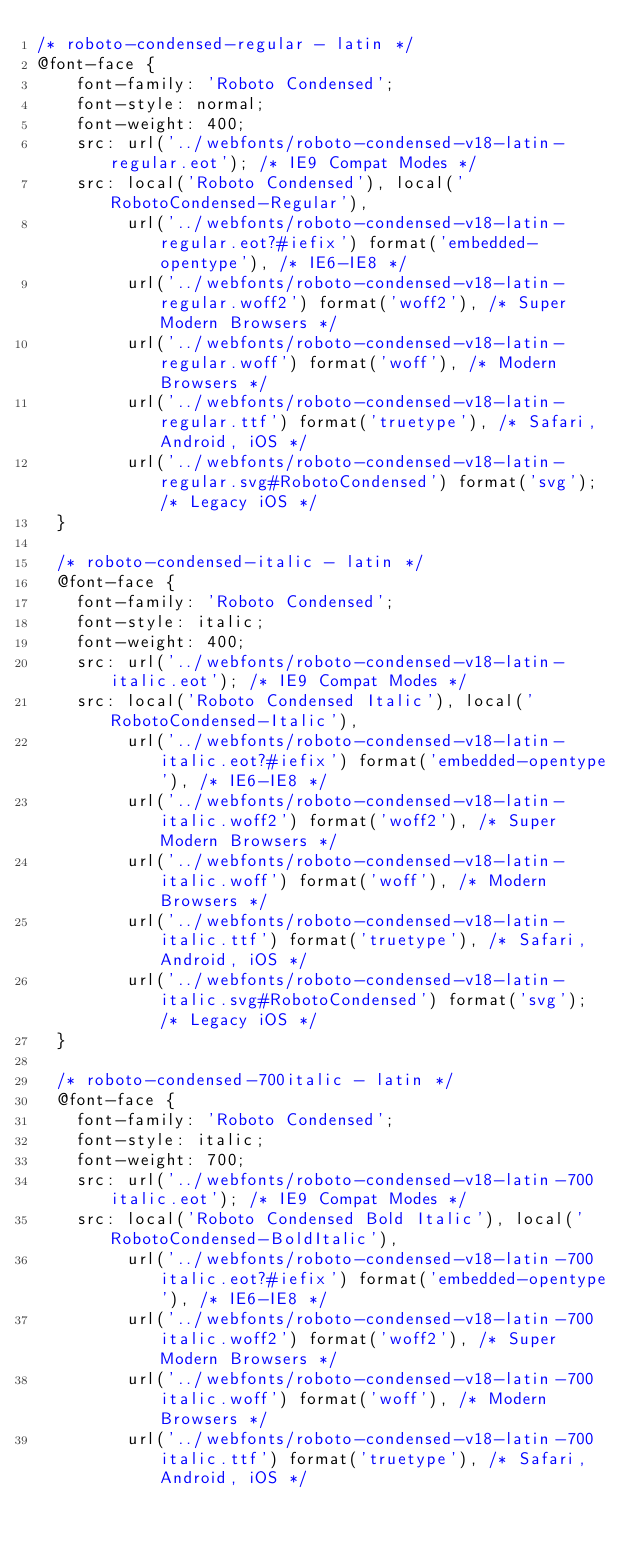<code> <loc_0><loc_0><loc_500><loc_500><_CSS_>/* roboto-condensed-regular - latin */
@font-face {
    font-family: 'Roboto Condensed';
    font-style: normal;
    font-weight: 400;
    src: url('../webfonts/roboto-condensed-v18-latin-regular.eot'); /* IE9 Compat Modes */
    src: local('Roboto Condensed'), local('RobotoCondensed-Regular'),
         url('../webfonts/roboto-condensed-v18-latin-regular.eot?#iefix') format('embedded-opentype'), /* IE6-IE8 */
         url('../webfonts/roboto-condensed-v18-latin-regular.woff2') format('woff2'), /* Super Modern Browsers */
         url('../webfonts/roboto-condensed-v18-latin-regular.woff') format('woff'), /* Modern Browsers */
         url('../webfonts/roboto-condensed-v18-latin-regular.ttf') format('truetype'), /* Safari, Android, iOS */
         url('../webfonts/roboto-condensed-v18-latin-regular.svg#RobotoCondensed') format('svg'); /* Legacy iOS */
  }
  
  /* roboto-condensed-italic - latin */
  @font-face {
    font-family: 'Roboto Condensed';
    font-style: italic;
    font-weight: 400;
    src: url('../webfonts/roboto-condensed-v18-latin-italic.eot'); /* IE9 Compat Modes */
    src: local('Roboto Condensed Italic'), local('RobotoCondensed-Italic'),
         url('../webfonts/roboto-condensed-v18-latin-italic.eot?#iefix') format('embedded-opentype'), /* IE6-IE8 */
         url('../webfonts/roboto-condensed-v18-latin-italic.woff2') format('woff2'), /* Super Modern Browsers */
         url('../webfonts/roboto-condensed-v18-latin-italic.woff') format('woff'), /* Modern Browsers */
         url('../webfonts/roboto-condensed-v18-latin-italic.ttf') format('truetype'), /* Safari, Android, iOS */
         url('../webfonts/roboto-condensed-v18-latin-italic.svg#RobotoCondensed') format('svg'); /* Legacy iOS */
  }
  
  /* roboto-condensed-700italic - latin */
  @font-face {
    font-family: 'Roboto Condensed';
    font-style: italic;
    font-weight: 700;
    src: url('../webfonts/roboto-condensed-v18-latin-700italic.eot'); /* IE9 Compat Modes */
    src: local('Roboto Condensed Bold Italic'), local('RobotoCondensed-BoldItalic'),
         url('../webfonts/roboto-condensed-v18-latin-700italic.eot?#iefix') format('embedded-opentype'), /* IE6-IE8 */
         url('../webfonts/roboto-condensed-v18-latin-700italic.woff2') format('woff2'), /* Super Modern Browsers */
         url('../webfonts/roboto-condensed-v18-latin-700italic.woff') format('woff'), /* Modern Browsers */
         url('../webfonts/roboto-condensed-v18-latin-700italic.ttf') format('truetype'), /* Safari, Android, iOS */</code> 